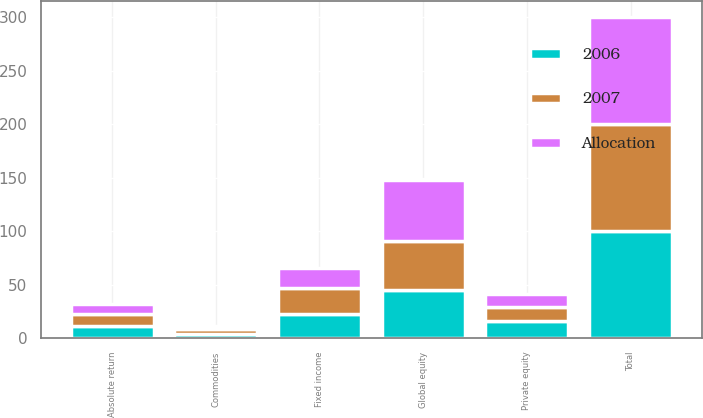Convert chart to OTSL. <chart><loc_0><loc_0><loc_500><loc_500><stacked_bar_chart><ecel><fcel>Global equity<fcel>Fixed income<fcel>Private equity<fcel>Absolute return<fcel>Commodities<fcel>Total<nl><fcel>2007<fcel>46<fcel>24<fcel>13<fcel>12<fcel>5<fcel>100<nl><fcel>2006<fcel>45<fcel>23<fcel>16<fcel>11<fcel>4<fcel>100<nl><fcel>Allocation<fcel>57<fcel>19<fcel>12<fcel>9<fcel>2<fcel>100<nl></chart> 